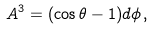<formula> <loc_0><loc_0><loc_500><loc_500>A ^ { 3 } = ( \cos \theta - 1 ) d \phi \, ,</formula> 